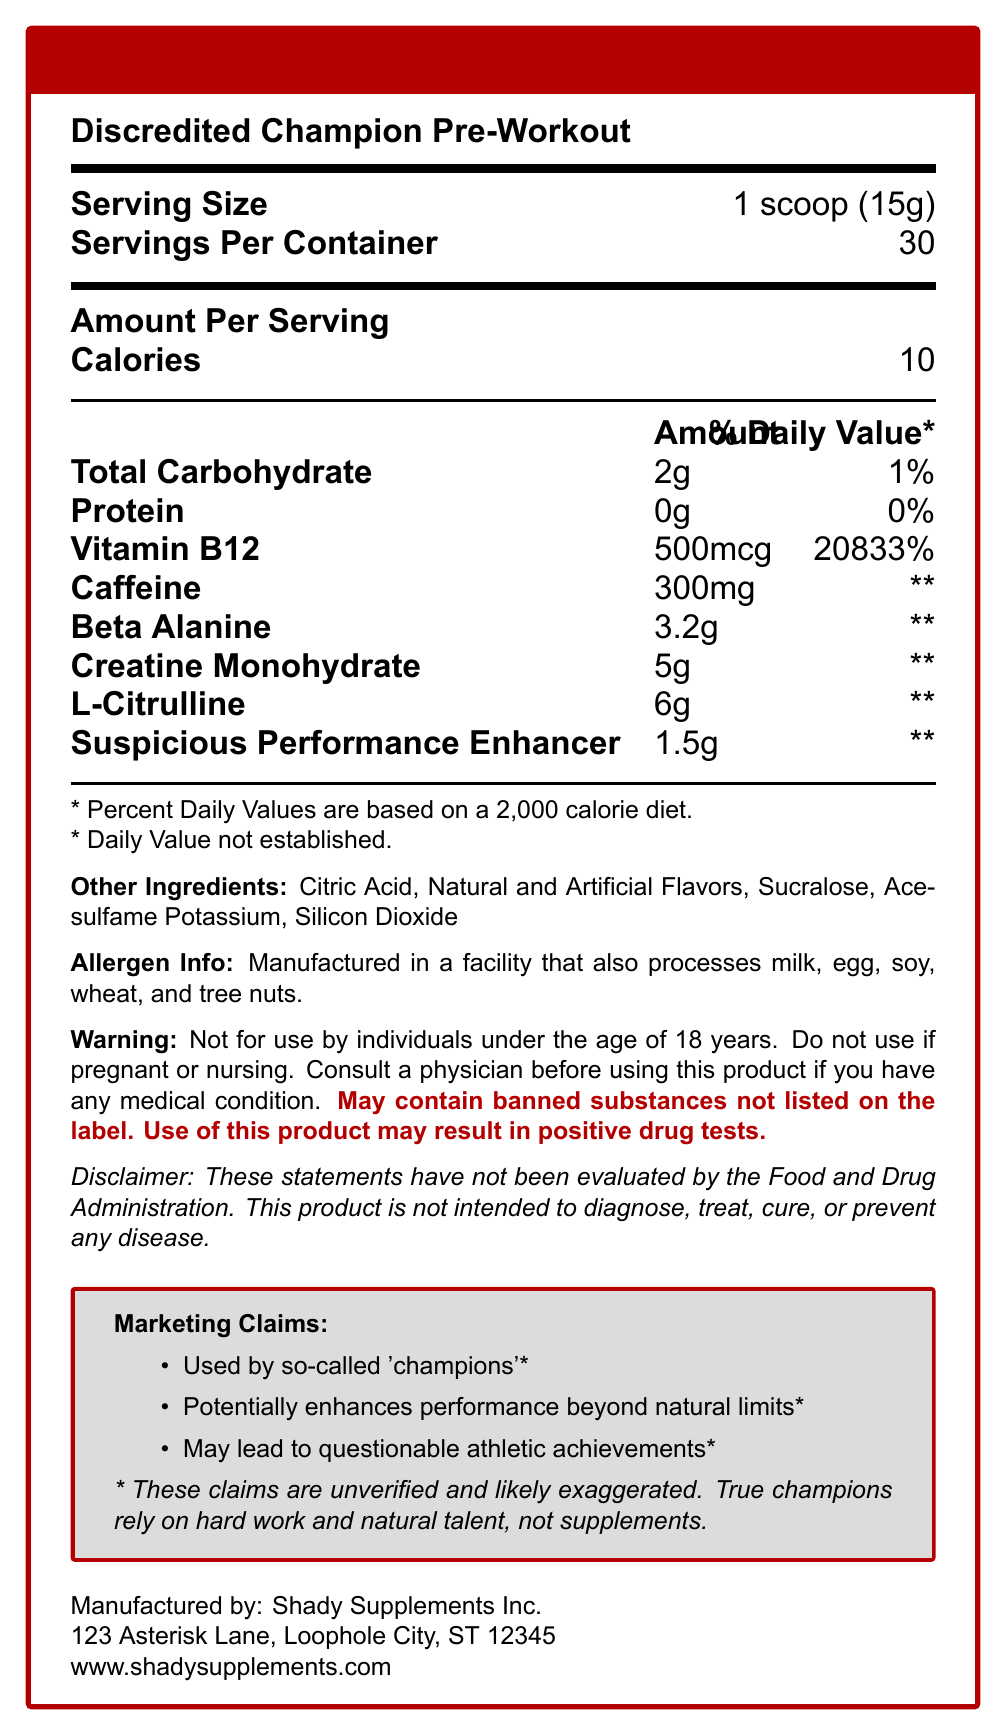what is the serving size? The serving size is clearly indicated at the beginning of the document as "1 scoop (15g)".
Answer: 1 scoop (15g) how many servings are there per container? The document shows this information next to the serving size details.
Answer: 30 how many calories are in one serving? The number of calories per serving is listed in the Amount Per Serving section.
Answer: 10 what warning is associated with the product's use? This warning appears in the warning section of the document.
Answer: May contain banned substances not listed on the label. Use of this product may result in positive drug tests. what ingredient has the highest percent daily value? Vitamin B12 has a daily value of 20833%, which is the highest among the listed ingredients.
Answer: Vitamin B12 which of the following is an ingredient in the "Discredited Champion Pre-Workout"? 
A. Aspartame 
B. Sucralose 
C. Saccharin 
D. Stevia The list of other ingredients includes Sucralose, but not Aspartame, Saccharin, or Stevia.
Answer: B. Sucralose how much caffeine is in one serving? 
A. 100mg 
B. 200mg 
C. 300mg 
D. 400mg The amount of caffeine per serving is listed as 300mg.
Answer: C. 300mg is this product recommended for use by pregnant or nursing individuals? The warning section states that the product should not be used by individuals who are pregnant or nursing.
Answer: No how many grams of creatine monohydrate are in one serving? This information is listed in the Amount Per Serving section under creatine monohydrate.
Answer: 5g does the product state it can enhance performance beyond natural limits? The Marketing Claims section mentions that the product "Potentially enhances performance beyond natural limits".
Answer: Yes what is the main idea of the document? The document provides comprehensive information about the nutrition facts and composition of the product, along with warnings and marketing claims that highlight the dubious nature of the supplement's benefits.
Answer: The document details the nutritional facts of the "Discredited Champion Pre-Workout" supplement, including serving size, key ingredients, warnings, and marketing claims with a focus on unverified claims and possible banned substances. what is the address of the manufacturer? The address is provided at the bottom of the document under the manufacturer's details.
Answer: 123 Asterisk Lane, Loophole City, ST 12345 does the product guarantee improved athletic performance? The product makes unverified claims about performance enhancement, but these are marked as likely exaggerated and unverified.
Answer: No how much beta-alanine is in one serving? This is listed in the Amount Per Serving section under beta-alanine.
Answer: 3.2g what are the potential risks associated with using this product? The warning section mentions the risk of banned substances not listed on the label and the potential for positive drug tests.
Answer: Positive drug tests, presence of banned substances how many grams of total carbohydrates are in one serving? The total carbohydrate amount per serving is listed as 2g.
Answer: 2g is the percentage of daily value for caffeine provided? The document states "\*\* Daily Value not established" for caffeine.
Answer: No 